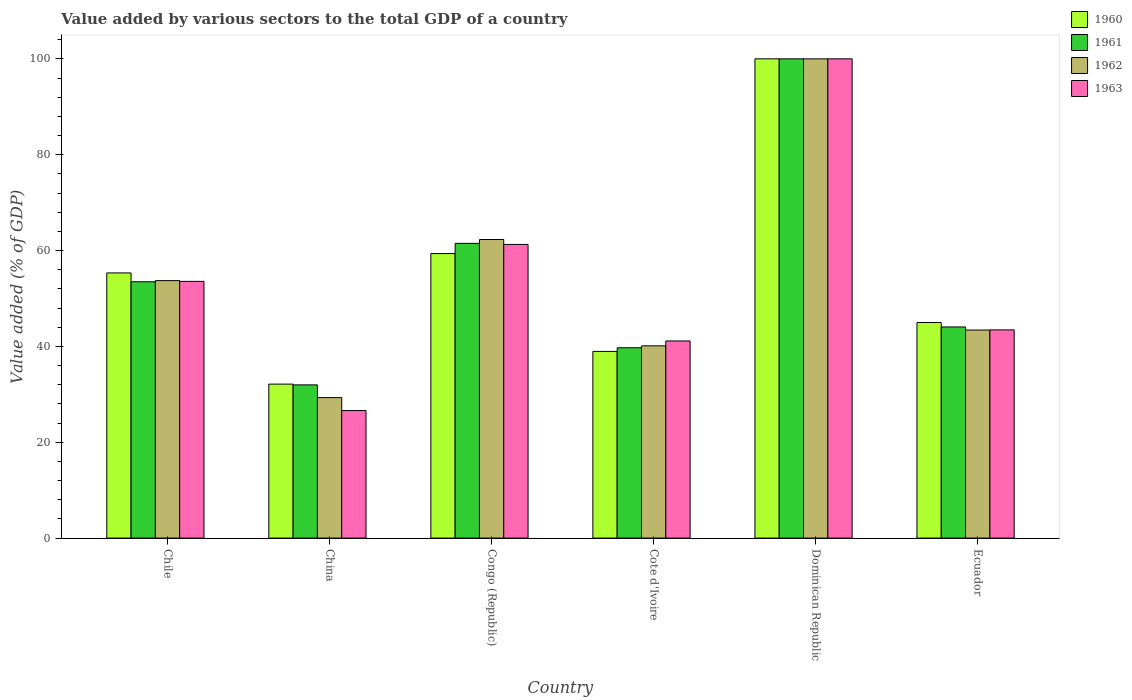How many different coloured bars are there?
Your answer should be compact. 4. Are the number of bars per tick equal to the number of legend labels?
Give a very brief answer. Yes. What is the label of the 2nd group of bars from the left?
Keep it short and to the point. China. What is the value added by various sectors to the total GDP in 1961 in Ecuador?
Provide a succinct answer. 44.05. Across all countries, what is the minimum value added by various sectors to the total GDP in 1961?
Offer a very short reply. 31.97. In which country was the value added by various sectors to the total GDP in 1961 maximum?
Give a very brief answer. Dominican Republic. In which country was the value added by various sectors to the total GDP in 1961 minimum?
Your answer should be very brief. China. What is the total value added by various sectors to the total GDP in 1961 in the graph?
Your answer should be very brief. 330.72. What is the difference between the value added by various sectors to the total GDP in 1962 in Chile and that in Cote d'Ivoire?
Offer a terse response. 13.61. What is the difference between the value added by various sectors to the total GDP in 1962 in Ecuador and the value added by various sectors to the total GDP in 1960 in Congo (Republic)?
Provide a short and direct response. -15.96. What is the average value added by various sectors to the total GDP in 1962 per country?
Offer a very short reply. 54.81. What is the difference between the value added by various sectors to the total GDP of/in 1961 and value added by various sectors to the total GDP of/in 1962 in Chile?
Keep it short and to the point. -0.24. What is the ratio of the value added by various sectors to the total GDP in 1961 in Congo (Republic) to that in Ecuador?
Offer a terse response. 1.4. What is the difference between the highest and the second highest value added by various sectors to the total GDP in 1961?
Make the answer very short. -46.51. What is the difference between the highest and the lowest value added by various sectors to the total GDP in 1963?
Provide a succinct answer. 73.39. Is it the case that in every country, the sum of the value added by various sectors to the total GDP in 1960 and value added by various sectors to the total GDP in 1963 is greater than the sum of value added by various sectors to the total GDP in 1962 and value added by various sectors to the total GDP in 1961?
Make the answer very short. No. What does the 2nd bar from the right in Cote d'Ivoire represents?
Your response must be concise. 1962. How many bars are there?
Your answer should be very brief. 24. Are all the bars in the graph horizontal?
Your answer should be compact. No. What is the difference between two consecutive major ticks on the Y-axis?
Your answer should be compact. 20. Are the values on the major ticks of Y-axis written in scientific E-notation?
Provide a succinct answer. No. Does the graph contain grids?
Your answer should be very brief. No. What is the title of the graph?
Provide a short and direct response. Value added by various sectors to the total GDP of a country. Does "1979" appear as one of the legend labels in the graph?
Keep it short and to the point. No. What is the label or title of the Y-axis?
Give a very brief answer. Value added (% of GDP). What is the Value added (% of GDP) of 1960 in Chile?
Keep it short and to the point. 55.33. What is the Value added (% of GDP) in 1961 in Chile?
Your answer should be very brief. 53.49. What is the Value added (% of GDP) of 1962 in Chile?
Provide a short and direct response. 53.72. What is the Value added (% of GDP) of 1963 in Chile?
Keep it short and to the point. 53.57. What is the Value added (% of GDP) in 1960 in China?
Keep it short and to the point. 32.13. What is the Value added (% of GDP) in 1961 in China?
Keep it short and to the point. 31.97. What is the Value added (% of GDP) in 1962 in China?
Give a very brief answer. 29.31. What is the Value added (% of GDP) in 1963 in China?
Your answer should be very brief. 26.61. What is the Value added (% of GDP) of 1960 in Congo (Republic)?
Give a very brief answer. 59.37. What is the Value added (% of GDP) in 1961 in Congo (Republic)?
Ensure brevity in your answer.  61.5. What is the Value added (% of GDP) of 1962 in Congo (Republic)?
Provide a short and direct response. 62.3. What is the Value added (% of GDP) in 1963 in Congo (Republic)?
Offer a very short reply. 61.27. What is the Value added (% of GDP) of 1960 in Cote d'Ivoire?
Provide a succinct answer. 38.95. What is the Value added (% of GDP) in 1961 in Cote d'Ivoire?
Ensure brevity in your answer.  39.71. What is the Value added (% of GDP) in 1962 in Cote d'Ivoire?
Keep it short and to the point. 40.11. What is the Value added (% of GDP) in 1963 in Cote d'Ivoire?
Make the answer very short. 41.13. What is the Value added (% of GDP) in 1960 in Dominican Republic?
Your response must be concise. 100. What is the Value added (% of GDP) in 1961 in Dominican Republic?
Offer a very short reply. 100. What is the Value added (% of GDP) of 1960 in Ecuador?
Keep it short and to the point. 44.99. What is the Value added (% of GDP) in 1961 in Ecuador?
Offer a very short reply. 44.05. What is the Value added (% of GDP) in 1962 in Ecuador?
Offer a very short reply. 43.41. What is the Value added (% of GDP) in 1963 in Ecuador?
Make the answer very short. 43.44. Across all countries, what is the maximum Value added (% of GDP) in 1962?
Make the answer very short. 100. Across all countries, what is the maximum Value added (% of GDP) of 1963?
Give a very brief answer. 100. Across all countries, what is the minimum Value added (% of GDP) in 1960?
Provide a succinct answer. 32.13. Across all countries, what is the minimum Value added (% of GDP) of 1961?
Provide a succinct answer. 31.97. Across all countries, what is the minimum Value added (% of GDP) in 1962?
Offer a terse response. 29.31. Across all countries, what is the minimum Value added (% of GDP) of 1963?
Give a very brief answer. 26.61. What is the total Value added (% of GDP) in 1960 in the graph?
Give a very brief answer. 330.77. What is the total Value added (% of GDP) in 1961 in the graph?
Make the answer very short. 330.72. What is the total Value added (% of GDP) of 1962 in the graph?
Offer a terse response. 328.87. What is the total Value added (% of GDP) in 1963 in the graph?
Keep it short and to the point. 326.02. What is the difference between the Value added (% of GDP) of 1960 in Chile and that in China?
Keep it short and to the point. 23.2. What is the difference between the Value added (% of GDP) in 1961 in Chile and that in China?
Offer a very short reply. 21.52. What is the difference between the Value added (% of GDP) in 1962 in Chile and that in China?
Make the answer very short. 24.41. What is the difference between the Value added (% of GDP) in 1963 in Chile and that in China?
Offer a terse response. 26.96. What is the difference between the Value added (% of GDP) of 1960 in Chile and that in Congo (Republic)?
Your answer should be very brief. -4.04. What is the difference between the Value added (% of GDP) in 1961 in Chile and that in Congo (Republic)?
Your response must be concise. -8.01. What is the difference between the Value added (% of GDP) in 1962 in Chile and that in Congo (Republic)?
Keep it short and to the point. -8.58. What is the difference between the Value added (% of GDP) in 1963 in Chile and that in Congo (Republic)?
Offer a very short reply. -7.71. What is the difference between the Value added (% of GDP) of 1960 in Chile and that in Cote d'Ivoire?
Offer a very short reply. 16.38. What is the difference between the Value added (% of GDP) in 1961 in Chile and that in Cote d'Ivoire?
Provide a succinct answer. 13.77. What is the difference between the Value added (% of GDP) in 1962 in Chile and that in Cote d'Ivoire?
Provide a succinct answer. 13.61. What is the difference between the Value added (% of GDP) in 1963 in Chile and that in Cote d'Ivoire?
Your answer should be very brief. 12.43. What is the difference between the Value added (% of GDP) in 1960 in Chile and that in Dominican Republic?
Your answer should be compact. -44.67. What is the difference between the Value added (% of GDP) in 1961 in Chile and that in Dominican Republic?
Offer a terse response. -46.51. What is the difference between the Value added (% of GDP) of 1962 in Chile and that in Dominican Republic?
Provide a short and direct response. -46.28. What is the difference between the Value added (% of GDP) in 1963 in Chile and that in Dominican Republic?
Provide a succinct answer. -46.43. What is the difference between the Value added (% of GDP) in 1960 in Chile and that in Ecuador?
Offer a very short reply. 10.34. What is the difference between the Value added (% of GDP) in 1961 in Chile and that in Ecuador?
Offer a terse response. 9.43. What is the difference between the Value added (% of GDP) of 1962 in Chile and that in Ecuador?
Keep it short and to the point. 10.31. What is the difference between the Value added (% of GDP) in 1963 in Chile and that in Ecuador?
Keep it short and to the point. 10.13. What is the difference between the Value added (% of GDP) in 1960 in China and that in Congo (Republic)?
Offer a very short reply. -27.24. What is the difference between the Value added (% of GDP) in 1961 in China and that in Congo (Republic)?
Provide a short and direct response. -29.53. What is the difference between the Value added (% of GDP) in 1962 in China and that in Congo (Republic)?
Provide a short and direct response. -32.99. What is the difference between the Value added (% of GDP) of 1963 in China and that in Congo (Republic)?
Give a very brief answer. -34.66. What is the difference between the Value added (% of GDP) of 1960 in China and that in Cote d'Ivoire?
Your answer should be compact. -6.83. What is the difference between the Value added (% of GDP) in 1961 in China and that in Cote d'Ivoire?
Provide a short and direct response. -7.75. What is the difference between the Value added (% of GDP) in 1962 in China and that in Cote d'Ivoire?
Ensure brevity in your answer.  -10.8. What is the difference between the Value added (% of GDP) of 1963 in China and that in Cote d'Ivoire?
Ensure brevity in your answer.  -14.52. What is the difference between the Value added (% of GDP) of 1960 in China and that in Dominican Republic?
Offer a very short reply. -67.87. What is the difference between the Value added (% of GDP) in 1961 in China and that in Dominican Republic?
Your response must be concise. -68.03. What is the difference between the Value added (% of GDP) of 1962 in China and that in Dominican Republic?
Offer a very short reply. -70.69. What is the difference between the Value added (% of GDP) of 1963 in China and that in Dominican Republic?
Ensure brevity in your answer.  -73.39. What is the difference between the Value added (% of GDP) in 1960 in China and that in Ecuador?
Offer a very short reply. -12.86. What is the difference between the Value added (% of GDP) in 1961 in China and that in Ecuador?
Ensure brevity in your answer.  -12.09. What is the difference between the Value added (% of GDP) in 1962 in China and that in Ecuador?
Your response must be concise. -14.1. What is the difference between the Value added (% of GDP) in 1963 in China and that in Ecuador?
Your answer should be compact. -16.83. What is the difference between the Value added (% of GDP) of 1960 in Congo (Republic) and that in Cote d'Ivoire?
Your response must be concise. 20.42. What is the difference between the Value added (% of GDP) of 1961 in Congo (Republic) and that in Cote d'Ivoire?
Give a very brief answer. 21.78. What is the difference between the Value added (% of GDP) of 1962 in Congo (Republic) and that in Cote d'Ivoire?
Make the answer very short. 22.19. What is the difference between the Value added (% of GDP) of 1963 in Congo (Republic) and that in Cote d'Ivoire?
Provide a short and direct response. 20.14. What is the difference between the Value added (% of GDP) in 1960 in Congo (Republic) and that in Dominican Republic?
Offer a terse response. -40.63. What is the difference between the Value added (% of GDP) of 1961 in Congo (Republic) and that in Dominican Republic?
Give a very brief answer. -38.5. What is the difference between the Value added (% of GDP) in 1962 in Congo (Republic) and that in Dominican Republic?
Keep it short and to the point. -37.7. What is the difference between the Value added (% of GDP) of 1963 in Congo (Republic) and that in Dominican Republic?
Offer a terse response. -38.73. What is the difference between the Value added (% of GDP) in 1960 in Congo (Republic) and that in Ecuador?
Provide a short and direct response. 14.39. What is the difference between the Value added (% of GDP) in 1961 in Congo (Republic) and that in Ecuador?
Ensure brevity in your answer.  17.44. What is the difference between the Value added (% of GDP) in 1962 in Congo (Republic) and that in Ecuador?
Provide a succinct answer. 18.89. What is the difference between the Value added (% of GDP) of 1963 in Congo (Republic) and that in Ecuador?
Give a very brief answer. 17.83. What is the difference between the Value added (% of GDP) in 1960 in Cote d'Ivoire and that in Dominican Republic?
Offer a terse response. -61.05. What is the difference between the Value added (% of GDP) in 1961 in Cote d'Ivoire and that in Dominican Republic?
Give a very brief answer. -60.29. What is the difference between the Value added (% of GDP) in 1962 in Cote d'Ivoire and that in Dominican Republic?
Keep it short and to the point. -59.89. What is the difference between the Value added (% of GDP) in 1963 in Cote d'Ivoire and that in Dominican Republic?
Make the answer very short. -58.87. What is the difference between the Value added (% of GDP) of 1960 in Cote d'Ivoire and that in Ecuador?
Provide a short and direct response. -6.03. What is the difference between the Value added (% of GDP) of 1961 in Cote d'Ivoire and that in Ecuador?
Your response must be concise. -4.34. What is the difference between the Value added (% of GDP) of 1962 in Cote d'Ivoire and that in Ecuador?
Make the answer very short. -3.3. What is the difference between the Value added (% of GDP) of 1963 in Cote d'Ivoire and that in Ecuador?
Offer a terse response. -2.31. What is the difference between the Value added (% of GDP) in 1960 in Dominican Republic and that in Ecuador?
Make the answer very short. 55.02. What is the difference between the Value added (% of GDP) of 1961 in Dominican Republic and that in Ecuador?
Offer a terse response. 55.95. What is the difference between the Value added (% of GDP) of 1962 in Dominican Republic and that in Ecuador?
Provide a succinct answer. 56.59. What is the difference between the Value added (% of GDP) of 1963 in Dominican Republic and that in Ecuador?
Provide a succinct answer. 56.56. What is the difference between the Value added (% of GDP) of 1960 in Chile and the Value added (% of GDP) of 1961 in China?
Give a very brief answer. 23.36. What is the difference between the Value added (% of GDP) in 1960 in Chile and the Value added (% of GDP) in 1962 in China?
Give a very brief answer. 26.02. What is the difference between the Value added (% of GDP) of 1960 in Chile and the Value added (% of GDP) of 1963 in China?
Provide a short and direct response. 28.72. What is the difference between the Value added (% of GDP) in 1961 in Chile and the Value added (% of GDP) in 1962 in China?
Provide a short and direct response. 24.17. What is the difference between the Value added (% of GDP) in 1961 in Chile and the Value added (% of GDP) in 1963 in China?
Your answer should be very brief. 26.87. What is the difference between the Value added (% of GDP) in 1962 in Chile and the Value added (% of GDP) in 1963 in China?
Provide a succinct answer. 27.11. What is the difference between the Value added (% of GDP) of 1960 in Chile and the Value added (% of GDP) of 1961 in Congo (Republic)?
Give a very brief answer. -6.17. What is the difference between the Value added (% of GDP) in 1960 in Chile and the Value added (% of GDP) in 1962 in Congo (Republic)?
Make the answer very short. -6.97. What is the difference between the Value added (% of GDP) of 1960 in Chile and the Value added (% of GDP) of 1963 in Congo (Republic)?
Offer a terse response. -5.94. What is the difference between the Value added (% of GDP) of 1961 in Chile and the Value added (% of GDP) of 1962 in Congo (Republic)?
Your response must be concise. -8.82. What is the difference between the Value added (% of GDP) in 1961 in Chile and the Value added (% of GDP) in 1963 in Congo (Republic)?
Give a very brief answer. -7.79. What is the difference between the Value added (% of GDP) in 1962 in Chile and the Value added (% of GDP) in 1963 in Congo (Republic)?
Offer a terse response. -7.55. What is the difference between the Value added (% of GDP) in 1960 in Chile and the Value added (% of GDP) in 1961 in Cote d'Ivoire?
Make the answer very short. 15.61. What is the difference between the Value added (% of GDP) in 1960 in Chile and the Value added (% of GDP) in 1962 in Cote d'Ivoire?
Keep it short and to the point. 15.21. What is the difference between the Value added (% of GDP) in 1960 in Chile and the Value added (% of GDP) in 1963 in Cote d'Ivoire?
Make the answer very short. 14.2. What is the difference between the Value added (% of GDP) of 1961 in Chile and the Value added (% of GDP) of 1962 in Cote d'Ivoire?
Your answer should be compact. 13.37. What is the difference between the Value added (% of GDP) in 1961 in Chile and the Value added (% of GDP) in 1963 in Cote d'Ivoire?
Your answer should be compact. 12.35. What is the difference between the Value added (% of GDP) in 1962 in Chile and the Value added (% of GDP) in 1963 in Cote d'Ivoire?
Make the answer very short. 12.59. What is the difference between the Value added (% of GDP) in 1960 in Chile and the Value added (% of GDP) in 1961 in Dominican Republic?
Provide a short and direct response. -44.67. What is the difference between the Value added (% of GDP) in 1960 in Chile and the Value added (% of GDP) in 1962 in Dominican Republic?
Your response must be concise. -44.67. What is the difference between the Value added (% of GDP) of 1960 in Chile and the Value added (% of GDP) of 1963 in Dominican Republic?
Offer a terse response. -44.67. What is the difference between the Value added (% of GDP) in 1961 in Chile and the Value added (% of GDP) in 1962 in Dominican Republic?
Make the answer very short. -46.51. What is the difference between the Value added (% of GDP) of 1961 in Chile and the Value added (% of GDP) of 1963 in Dominican Republic?
Give a very brief answer. -46.51. What is the difference between the Value added (% of GDP) in 1962 in Chile and the Value added (% of GDP) in 1963 in Dominican Republic?
Ensure brevity in your answer.  -46.28. What is the difference between the Value added (% of GDP) of 1960 in Chile and the Value added (% of GDP) of 1961 in Ecuador?
Ensure brevity in your answer.  11.28. What is the difference between the Value added (% of GDP) of 1960 in Chile and the Value added (% of GDP) of 1962 in Ecuador?
Ensure brevity in your answer.  11.92. What is the difference between the Value added (% of GDP) of 1960 in Chile and the Value added (% of GDP) of 1963 in Ecuador?
Offer a terse response. 11.89. What is the difference between the Value added (% of GDP) of 1961 in Chile and the Value added (% of GDP) of 1962 in Ecuador?
Your response must be concise. 10.07. What is the difference between the Value added (% of GDP) of 1961 in Chile and the Value added (% of GDP) of 1963 in Ecuador?
Ensure brevity in your answer.  10.04. What is the difference between the Value added (% of GDP) of 1962 in Chile and the Value added (% of GDP) of 1963 in Ecuador?
Your answer should be compact. 10.28. What is the difference between the Value added (% of GDP) of 1960 in China and the Value added (% of GDP) of 1961 in Congo (Republic)?
Give a very brief answer. -29.37. What is the difference between the Value added (% of GDP) in 1960 in China and the Value added (% of GDP) in 1962 in Congo (Republic)?
Give a very brief answer. -30.18. What is the difference between the Value added (% of GDP) in 1960 in China and the Value added (% of GDP) in 1963 in Congo (Republic)?
Provide a short and direct response. -29.15. What is the difference between the Value added (% of GDP) in 1961 in China and the Value added (% of GDP) in 1962 in Congo (Republic)?
Ensure brevity in your answer.  -30.34. What is the difference between the Value added (% of GDP) in 1961 in China and the Value added (% of GDP) in 1963 in Congo (Republic)?
Give a very brief answer. -29.31. What is the difference between the Value added (% of GDP) of 1962 in China and the Value added (% of GDP) of 1963 in Congo (Republic)?
Keep it short and to the point. -31.96. What is the difference between the Value added (% of GDP) of 1960 in China and the Value added (% of GDP) of 1961 in Cote d'Ivoire?
Offer a terse response. -7.59. What is the difference between the Value added (% of GDP) in 1960 in China and the Value added (% of GDP) in 1962 in Cote d'Ivoire?
Make the answer very short. -7.99. What is the difference between the Value added (% of GDP) of 1960 in China and the Value added (% of GDP) of 1963 in Cote d'Ivoire?
Make the answer very short. -9.01. What is the difference between the Value added (% of GDP) of 1961 in China and the Value added (% of GDP) of 1962 in Cote d'Ivoire?
Make the answer very short. -8.15. What is the difference between the Value added (% of GDP) in 1961 in China and the Value added (% of GDP) in 1963 in Cote d'Ivoire?
Your response must be concise. -9.17. What is the difference between the Value added (% of GDP) of 1962 in China and the Value added (% of GDP) of 1963 in Cote d'Ivoire?
Offer a very short reply. -11.82. What is the difference between the Value added (% of GDP) of 1960 in China and the Value added (% of GDP) of 1961 in Dominican Republic?
Ensure brevity in your answer.  -67.87. What is the difference between the Value added (% of GDP) of 1960 in China and the Value added (% of GDP) of 1962 in Dominican Republic?
Keep it short and to the point. -67.87. What is the difference between the Value added (% of GDP) of 1960 in China and the Value added (% of GDP) of 1963 in Dominican Republic?
Keep it short and to the point. -67.87. What is the difference between the Value added (% of GDP) in 1961 in China and the Value added (% of GDP) in 1962 in Dominican Republic?
Keep it short and to the point. -68.03. What is the difference between the Value added (% of GDP) in 1961 in China and the Value added (% of GDP) in 1963 in Dominican Republic?
Offer a very short reply. -68.03. What is the difference between the Value added (% of GDP) of 1962 in China and the Value added (% of GDP) of 1963 in Dominican Republic?
Give a very brief answer. -70.69. What is the difference between the Value added (% of GDP) of 1960 in China and the Value added (% of GDP) of 1961 in Ecuador?
Ensure brevity in your answer.  -11.93. What is the difference between the Value added (% of GDP) in 1960 in China and the Value added (% of GDP) in 1962 in Ecuador?
Make the answer very short. -11.29. What is the difference between the Value added (% of GDP) in 1960 in China and the Value added (% of GDP) in 1963 in Ecuador?
Keep it short and to the point. -11.31. What is the difference between the Value added (% of GDP) of 1961 in China and the Value added (% of GDP) of 1962 in Ecuador?
Provide a succinct answer. -11.45. What is the difference between the Value added (% of GDP) of 1961 in China and the Value added (% of GDP) of 1963 in Ecuador?
Your response must be concise. -11.47. What is the difference between the Value added (% of GDP) in 1962 in China and the Value added (% of GDP) in 1963 in Ecuador?
Provide a succinct answer. -14.13. What is the difference between the Value added (% of GDP) of 1960 in Congo (Republic) and the Value added (% of GDP) of 1961 in Cote d'Ivoire?
Provide a succinct answer. 19.66. What is the difference between the Value added (% of GDP) of 1960 in Congo (Republic) and the Value added (% of GDP) of 1962 in Cote d'Ivoire?
Ensure brevity in your answer.  19.26. What is the difference between the Value added (% of GDP) in 1960 in Congo (Republic) and the Value added (% of GDP) in 1963 in Cote d'Ivoire?
Keep it short and to the point. 18.24. What is the difference between the Value added (% of GDP) in 1961 in Congo (Republic) and the Value added (% of GDP) in 1962 in Cote d'Ivoire?
Give a very brief answer. 21.38. What is the difference between the Value added (% of GDP) of 1961 in Congo (Republic) and the Value added (% of GDP) of 1963 in Cote d'Ivoire?
Offer a terse response. 20.36. What is the difference between the Value added (% of GDP) in 1962 in Congo (Republic) and the Value added (% of GDP) in 1963 in Cote d'Ivoire?
Ensure brevity in your answer.  21.17. What is the difference between the Value added (% of GDP) of 1960 in Congo (Republic) and the Value added (% of GDP) of 1961 in Dominican Republic?
Offer a very short reply. -40.63. What is the difference between the Value added (% of GDP) in 1960 in Congo (Republic) and the Value added (% of GDP) in 1962 in Dominican Republic?
Give a very brief answer. -40.63. What is the difference between the Value added (% of GDP) of 1960 in Congo (Republic) and the Value added (% of GDP) of 1963 in Dominican Republic?
Provide a short and direct response. -40.63. What is the difference between the Value added (% of GDP) in 1961 in Congo (Republic) and the Value added (% of GDP) in 1962 in Dominican Republic?
Offer a very short reply. -38.5. What is the difference between the Value added (% of GDP) in 1961 in Congo (Republic) and the Value added (% of GDP) in 1963 in Dominican Republic?
Offer a terse response. -38.5. What is the difference between the Value added (% of GDP) in 1962 in Congo (Republic) and the Value added (% of GDP) in 1963 in Dominican Republic?
Your answer should be compact. -37.7. What is the difference between the Value added (% of GDP) of 1960 in Congo (Republic) and the Value added (% of GDP) of 1961 in Ecuador?
Keep it short and to the point. 15.32. What is the difference between the Value added (% of GDP) of 1960 in Congo (Republic) and the Value added (% of GDP) of 1962 in Ecuador?
Provide a succinct answer. 15.96. What is the difference between the Value added (% of GDP) of 1960 in Congo (Republic) and the Value added (% of GDP) of 1963 in Ecuador?
Your answer should be very brief. 15.93. What is the difference between the Value added (% of GDP) of 1961 in Congo (Republic) and the Value added (% of GDP) of 1962 in Ecuador?
Keep it short and to the point. 18.08. What is the difference between the Value added (% of GDP) in 1961 in Congo (Republic) and the Value added (% of GDP) in 1963 in Ecuador?
Provide a succinct answer. 18.06. What is the difference between the Value added (% of GDP) of 1962 in Congo (Republic) and the Value added (% of GDP) of 1963 in Ecuador?
Provide a succinct answer. 18.86. What is the difference between the Value added (% of GDP) in 1960 in Cote d'Ivoire and the Value added (% of GDP) in 1961 in Dominican Republic?
Provide a short and direct response. -61.05. What is the difference between the Value added (% of GDP) of 1960 in Cote d'Ivoire and the Value added (% of GDP) of 1962 in Dominican Republic?
Your response must be concise. -61.05. What is the difference between the Value added (% of GDP) of 1960 in Cote d'Ivoire and the Value added (% of GDP) of 1963 in Dominican Republic?
Provide a short and direct response. -61.05. What is the difference between the Value added (% of GDP) of 1961 in Cote d'Ivoire and the Value added (% of GDP) of 1962 in Dominican Republic?
Your answer should be very brief. -60.29. What is the difference between the Value added (% of GDP) in 1961 in Cote d'Ivoire and the Value added (% of GDP) in 1963 in Dominican Republic?
Provide a short and direct response. -60.29. What is the difference between the Value added (% of GDP) of 1962 in Cote d'Ivoire and the Value added (% of GDP) of 1963 in Dominican Republic?
Provide a short and direct response. -59.89. What is the difference between the Value added (% of GDP) of 1960 in Cote d'Ivoire and the Value added (% of GDP) of 1961 in Ecuador?
Your response must be concise. -5.1. What is the difference between the Value added (% of GDP) of 1960 in Cote d'Ivoire and the Value added (% of GDP) of 1962 in Ecuador?
Offer a terse response. -4.46. What is the difference between the Value added (% of GDP) in 1960 in Cote d'Ivoire and the Value added (% of GDP) in 1963 in Ecuador?
Your answer should be very brief. -4.49. What is the difference between the Value added (% of GDP) of 1961 in Cote d'Ivoire and the Value added (% of GDP) of 1962 in Ecuador?
Ensure brevity in your answer.  -3.7. What is the difference between the Value added (% of GDP) of 1961 in Cote d'Ivoire and the Value added (% of GDP) of 1963 in Ecuador?
Provide a succinct answer. -3.73. What is the difference between the Value added (% of GDP) of 1962 in Cote d'Ivoire and the Value added (% of GDP) of 1963 in Ecuador?
Offer a very short reply. -3.33. What is the difference between the Value added (% of GDP) in 1960 in Dominican Republic and the Value added (% of GDP) in 1961 in Ecuador?
Offer a terse response. 55.95. What is the difference between the Value added (% of GDP) of 1960 in Dominican Republic and the Value added (% of GDP) of 1962 in Ecuador?
Give a very brief answer. 56.59. What is the difference between the Value added (% of GDP) in 1960 in Dominican Republic and the Value added (% of GDP) in 1963 in Ecuador?
Offer a terse response. 56.56. What is the difference between the Value added (% of GDP) of 1961 in Dominican Republic and the Value added (% of GDP) of 1962 in Ecuador?
Offer a terse response. 56.59. What is the difference between the Value added (% of GDP) in 1961 in Dominican Republic and the Value added (% of GDP) in 1963 in Ecuador?
Your answer should be very brief. 56.56. What is the difference between the Value added (% of GDP) of 1962 in Dominican Republic and the Value added (% of GDP) of 1963 in Ecuador?
Give a very brief answer. 56.56. What is the average Value added (% of GDP) of 1960 per country?
Your response must be concise. 55.13. What is the average Value added (% of GDP) of 1961 per country?
Your answer should be very brief. 55.12. What is the average Value added (% of GDP) of 1962 per country?
Your response must be concise. 54.81. What is the average Value added (% of GDP) in 1963 per country?
Your answer should be compact. 54.34. What is the difference between the Value added (% of GDP) in 1960 and Value added (% of GDP) in 1961 in Chile?
Your answer should be compact. 1.84. What is the difference between the Value added (% of GDP) of 1960 and Value added (% of GDP) of 1962 in Chile?
Provide a short and direct response. 1.6. What is the difference between the Value added (% of GDP) of 1960 and Value added (% of GDP) of 1963 in Chile?
Make the answer very short. 1.76. What is the difference between the Value added (% of GDP) in 1961 and Value added (% of GDP) in 1962 in Chile?
Your response must be concise. -0.24. What is the difference between the Value added (% of GDP) of 1961 and Value added (% of GDP) of 1963 in Chile?
Provide a succinct answer. -0.08. What is the difference between the Value added (% of GDP) in 1962 and Value added (% of GDP) in 1963 in Chile?
Provide a short and direct response. 0.16. What is the difference between the Value added (% of GDP) of 1960 and Value added (% of GDP) of 1961 in China?
Provide a succinct answer. 0.16. What is the difference between the Value added (% of GDP) in 1960 and Value added (% of GDP) in 1962 in China?
Offer a terse response. 2.81. What is the difference between the Value added (% of GDP) of 1960 and Value added (% of GDP) of 1963 in China?
Provide a succinct answer. 5.52. What is the difference between the Value added (% of GDP) of 1961 and Value added (% of GDP) of 1962 in China?
Your answer should be compact. 2.65. What is the difference between the Value added (% of GDP) in 1961 and Value added (% of GDP) in 1963 in China?
Provide a succinct answer. 5.36. What is the difference between the Value added (% of GDP) of 1962 and Value added (% of GDP) of 1963 in China?
Offer a very short reply. 2.7. What is the difference between the Value added (% of GDP) in 1960 and Value added (% of GDP) in 1961 in Congo (Republic)?
Your answer should be compact. -2.13. What is the difference between the Value added (% of GDP) in 1960 and Value added (% of GDP) in 1962 in Congo (Republic)?
Give a very brief answer. -2.93. What is the difference between the Value added (% of GDP) of 1960 and Value added (% of GDP) of 1963 in Congo (Republic)?
Your answer should be very brief. -1.9. What is the difference between the Value added (% of GDP) of 1961 and Value added (% of GDP) of 1962 in Congo (Republic)?
Provide a succinct answer. -0.81. What is the difference between the Value added (% of GDP) of 1961 and Value added (% of GDP) of 1963 in Congo (Republic)?
Give a very brief answer. 0.22. What is the difference between the Value added (% of GDP) of 1962 and Value added (% of GDP) of 1963 in Congo (Republic)?
Offer a very short reply. 1.03. What is the difference between the Value added (% of GDP) in 1960 and Value added (% of GDP) in 1961 in Cote d'Ivoire?
Ensure brevity in your answer.  -0.76. What is the difference between the Value added (% of GDP) of 1960 and Value added (% of GDP) of 1962 in Cote d'Ivoire?
Keep it short and to the point. -1.16. What is the difference between the Value added (% of GDP) in 1960 and Value added (% of GDP) in 1963 in Cote d'Ivoire?
Offer a very short reply. -2.18. What is the difference between the Value added (% of GDP) of 1961 and Value added (% of GDP) of 1962 in Cote d'Ivoire?
Keep it short and to the point. -0.4. What is the difference between the Value added (% of GDP) of 1961 and Value added (% of GDP) of 1963 in Cote d'Ivoire?
Offer a very short reply. -1.42. What is the difference between the Value added (% of GDP) in 1962 and Value added (% of GDP) in 1963 in Cote d'Ivoire?
Give a very brief answer. -1.02. What is the difference between the Value added (% of GDP) in 1960 and Value added (% of GDP) in 1961 in Dominican Republic?
Your answer should be compact. 0. What is the difference between the Value added (% of GDP) of 1960 and Value added (% of GDP) of 1962 in Dominican Republic?
Make the answer very short. 0. What is the difference between the Value added (% of GDP) in 1961 and Value added (% of GDP) in 1962 in Dominican Republic?
Your answer should be compact. 0. What is the difference between the Value added (% of GDP) of 1961 and Value added (% of GDP) of 1963 in Dominican Republic?
Your answer should be very brief. 0. What is the difference between the Value added (% of GDP) in 1962 and Value added (% of GDP) in 1963 in Dominican Republic?
Your response must be concise. 0. What is the difference between the Value added (% of GDP) in 1960 and Value added (% of GDP) in 1961 in Ecuador?
Make the answer very short. 0.93. What is the difference between the Value added (% of GDP) of 1960 and Value added (% of GDP) of 1962 in Ecuador?
Provide a short and direct response. 1.57. What is the difference between the Value added (% of GDP) in 1960 and Value added (% of GDP) in 1963 in Ecuador?
Offer a very short reply. 1.54. What is the difference between the Value added (% of GDP) in 1961 and Value added (% of GDP) in 1962 in Ecuador?
Provide a short and direct response. 0.64. What is the difference between the Value added (% of GDP) in 1961 and Value added (% of GDP) in 1963 in Ecuador?
Keep it short and to the point. 0.61. What is the difference between the Value added (% of GDP) of 1962 and Value added (% of GDP) of 1963 in Ecuador?
Make the answer very short. -0.03. What is the ratio of the Value added (% of GDP) in 1960 in Chile to that in China?
Give a very brief answer. 1.72. What is the ratio of the Value added (% of GDP) of 1961 in Chile to that in China?
Provide a succinct answer. 1.67. What is the ratio of the Value added (% of GDP) in 1962 in Chile to that in China?
Make the answer very short. 1.83. What is the ratio of the Value added (% of GDP) in 1963 in Chile to that in China?
Keep it short and to the point. 2.01. What is the ratio of the Value added (% of GDP) in 1960 in Chile to that in Congo (Republic)?
Provide a short and direct response. 0.93. What is the ratio of the Value added (% of GDP) in 1961 in Chile to that in Congo (Republic)?
Offer a very short reply. 0.87. What is the ratio of the Value added (% of GDP) of 1962 in Chile to that in Congo (Republic)?
Make the answer very short. 0.86. What is the ratio of the Value added (% of GDP) in 1963 in Chile to that in Congo (Republic)?
Offer a very short reply. 0.87. What is the ratio of the Value added (% of GDP) of 1960 in Chile to that in Cote d'Ivoire?
Ensure brevity in your answer.  1.42. What is the ratio of the Value added (% of GDP) in 1961 in Chile to that in Cote d'Ivoire?
Keep it short and to the point. 1.35. What is the ratio of the Value added (% of GDP) of 1962 in Chile to that in Cote d'Ivoire?
Your response must be concise. 1.34. What is the ratio of the Value added (% of GDP) of 1963 in Chile to that in Cote d'Ivoire?
Keep it short and to the point. 1.3. What is the ratio of the Value added (% of GDP) in 1960 in Chile to that in Dominican Republic?
Offer a terse response. 0.55. What is the ratio of the Value added (% of GDP) of 1961 in Chile to that in Dominican Republic?
Your answer should be compact. 0.53. What is the ratio of the Value added (% of GDP) of 1962 in Chile to that in Dominican Republic?
Give a very brief answer. 0.54. What is the ratio of the Value added (% of GDP) in 1963 in Chile to that in Dominican Republic?
Provide a short and direct response. 0.54. What is the ratio of the Value added (% of GDP) in 1960 in Chile to that in Ecuador?
Your answer should be compact. 1.23. What is the ratio of the Value added (% of GDP) in 1961 in Chile to that in Ecuador?
Your response must be concise. 1.21. What is the ratio of the Value added (% of GDP) in 1962 in Chile to that in Ecuador?
Provide a short and direct response. 1.24. What is the ratio of the Value added (% of GDP) in 1963 in Chile to that in Ecuador?
Your answer should be compact. 1.23. What is the ratio of the Value added (% of GDP) in 1960 in China to that in Congo (Republic)?
Make the answer very short. 0.54. What is the ratio of the Value added (% of GDP) in 1961 in China to that in Congo (Republic)?
Provide a short and direct response. 0.52. What is the ratio of the Value added (% of GDP) of 1962 in China to that in Congo (Republic)?
Offer a very short reply. 0.47. What is the ratio of the Value added (% of GDP) in 1963 in China to that in Congo (Republic)?
Make the answer very short. 0.43. What is the ratio of the Value added (% of GDP) in 1960 in China to that in Cote d'Ivoire?
Make the answer very short. 0.82. What is the ratio of the Value added (% of GDP) in 1961 in China to that in Cote d'Ivoire?
Your answer should be very brief. 0.8. What is the ratio of the Value added (% of GDP) in 1962 in China to that in Cote d'Ivoire?
Offer a terse response. 0.73. What is the ratio of the Value added (% of GDP) of 1963 in China to that in Cote d'Ivoire?
Make the answer very short. 0.65. What is the ratio of the Value added (% of GDP) of 1960 in China to that in Dominican Republic?
Offer a very short reply. 0.32. What is the ratio of the Value added (% of GDP) in 1961 in China to that in Dominican Republic?
Give a very brief answer. 0.32. What is the ratio of the Value added (% of GDP) of 1962 in China to that in Dominican Republic?
Make the answer very short. 0.29. What is the ratio of the Value added (% of GDP) in 1963 in China to that in Dominican Republic?
Keep it short and to the point. 0.27. What is the ratio of the Value added (% of GDP) in 1960 in China to that in Ecuador?
Keep it short and to the point. 0.71. What is the ratio of the Value added (% of GDP) of 1961 in China to that in Ecuador?
Your answer should be very brief. 0.73. What is the ratio of the Value added (% of GDP) of 1962 in China to that in Ecuador?
Your answer should be very brief. 0.68. What is the ratio of the Value added (% of GDP) in 1963 in China to that in Ecuador?
Provide a succinct answer. 0.61. What is the ratio of the Value added (% of GDP) of 1960 in Congo (Republic) to that in Cote d'Ivoire?
Keep it short and to the point. 1.52. What is the ratio of the Value added (% of GDP) in 1961 in Congo (Republic) to that in Cote d'Ivoire?
Your response must be concise. 1.55. What is the ratio of the Value added (% of GDP) in 1962 in Congo (Republic) to that in Cote d'Ivoire?
Your answer should be compact. 1.55. What is the ratio of the Value added (% of GDP) of 1963 in Congo (Republic) to that in Cote d'Ivoire?
Your answer should be very brief. 1.49. What is the ratio of the Value added (% of GDP) in 1960 in Congo (Republic) to that in Dominican Republic?
Your response must be concise. 0.59. What is the ratio of the Value added (% of GDP) in 1961 in Congo (Republic) to that in Dominican Republic?
Provide a short and direct response. 0.61. What is the ratio of the Value added (% of GDP) in 1962 in Congo (Republic) to that in Dominican Republic?
Give a very brief answer. 0.62. What is the ratio of the Value added (% of GDP) of 1963 in Congo (Republic) to that in Dominican Republic?
Keep it short and to the point. 0.61. What is the ratio of the Value added (% of GDP) in 1960 in Congo (Republic) to that in Ecuador?
Keep it short and to the point. 1.32. What is the ratio of the Value added (% of GDP) of 1961 in Congo (Republic) to that in Ecuador?
Keep it short and to the point. 1.4. What is the ratio of the Value added (% of GDP) of 1962 in Congo (Republic) to that in Ecuador?
Ensure brevity in your answer.  1.44. What is the ratio of the Value added (% of GDP) of 1963 in Congo (Republic) to that in Ecuador?
Your answer should be very brief. 1.41. What is the ratio of the Value added (% of GDP) in 1960 in Cote d'Ivoire to that in Dominican Republic?
Your response must be concise. 0.39. What is the ratio of the Value added (% of GDP) of 1961 in Cote d'Ivoire to that in Dominican Republic?
Provide a short and direct response. 0.4. What is the ratio of the Value added (% of GDP) of 1962 in Cote d'Ivoire to that in Dominican Republic?
Ensure brevity in your answer.  0.4. What is the ratio of the Value added (% of GDP) in 1963 in Cote d'Ivoire to that in Dominican Republic?
Provide a short and direct response. 0.41. What is the ratio of the Value added (% of GDP) of 1960 in Cote d'Ivoire to that in Ecuador?
Your response must be concise. 0.87. What is the ratio of the Value added (% of GDP) in 1961 in Cote d'Ivoire to that in Ecuador?
Keep it short and to the point. 0.9. What is the ratio of the Value added (% of GDP) in 1962 in Cote d'Ivoire to that in Ecuador?
Offer a terse response. 0.92. What is the ratio of the Value added (% of GDP) in 1963 in Cote d'Ivoire to that in Ecuador?
Your answer should be very brief. 0.95. What is the ratio of the Value added (% of GDP) of 1960 in Dominican Republic to that in Ecuador?
Offer a very short reply. 2.22. What is the ratio of the Value added (% of GDP) of 1961 in Dominican Republic to that in Ecuador?
Your answer should be compact. 2.27. What is the ratio of the Value added (% of GDP) of 1962 in Dominican Republic to that in Ecuador?
Give a very brief answer. 2.3. What is the ratio of the Value added (% of GDP) in 1963 in Dominican Republic to that in Ecuador?
Provide a short and direct response. 2.3. What is the difference between the highest and the second highest Value added (% of GDP) of 1960?
Your answer should be compact. 40.63. What is the difference between the highest and the second highest Value added (% of GDP) of 1961?
Make the answer very short. 38.5. What is the difference between the highest and the second highest Value added (% of GDP) in 1962?
Give a very brief answer. 37.7. What is the difference between the highest and the second highest Value added (% of GDP) of 1963?
Your answer should be very brief. 38.73. What is the difference between the highest and the lowest Value added (% of GDP) of 1960?
Your response must be concise. 67.87. What is the difference between the highest and the lowest Value added (% of GDP) in 1961?
Give a very brief answer. 68.03. What is the difference between the highest and the lowest Value added (% of GDP) of 1962?
Make the answer very short. 70.69. What is the difference between the highest and the lowest Value added (% of GDP) of 1963?
Your response must be concise. 73.39. 